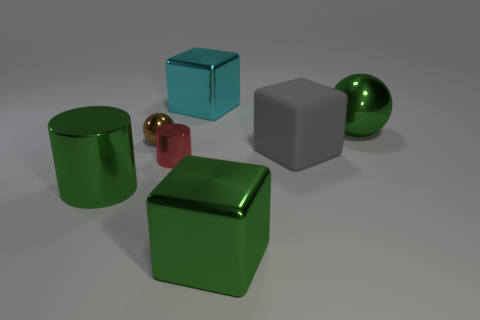Is there a metallic object that has the same color as the large metal cylinder?
Provide a succinct answer. Yes. Is there a small purple metallic block?
Give a very brief answer. No. What shape is the green object behind the small red cylinder?
Provide a succinct answer. Sphere. What number of green shiny things are both behind the large green block and in front of the small red thing?
Make the answer very short. 1. How many other things are there of the same size as the brown object?
Provide a succinct answer. 1. Is the shape of the shiny thing that is on the left side of the tiny brown ball the same as the small metallic object that is in front of the gray object?
Ensure brevity in your answer.  Yes. What number of things are either green shiny balls or big cubes that are behind the tiny red metal cylinder?
Your answer should be compact. 3. The big green object that is both in front of the brown sphere and behind the green metal cube is made of what material?
Give a very brief answer. Metal. What color is the tiny cylinder that is the same material as the big cyan object?
Offer a very short reply. Red. What number of things are either green rubber blocks or big gray things?
Provide a short and direct response. 1. 